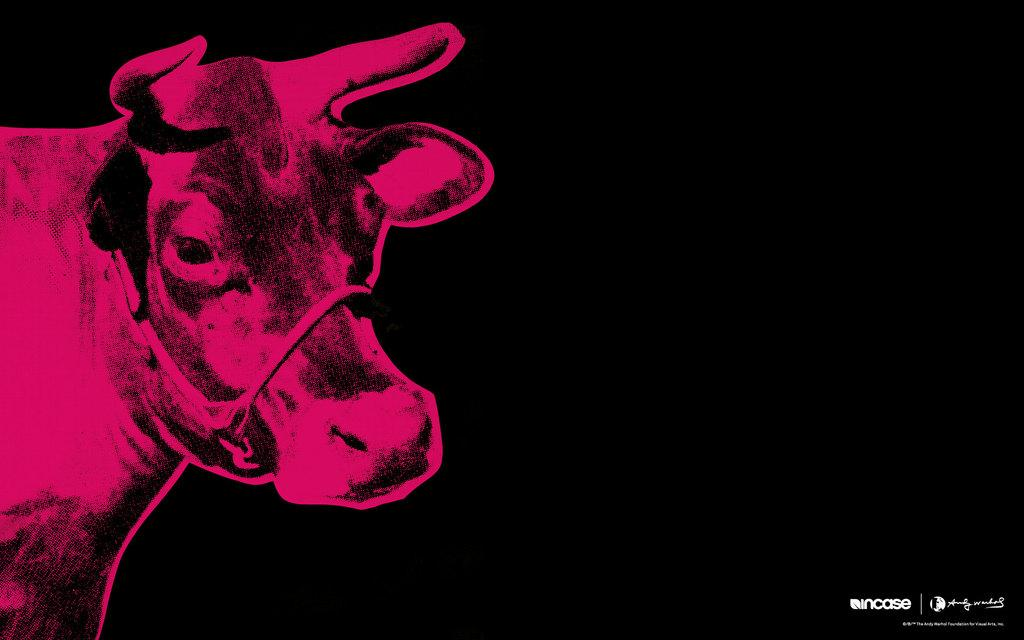What is the main subject of the image? There is a picture of an animal in the image. What type of beef is being served on the table in the image? There is no table or beef present in the image; it only features a picture of an animal. 